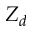<formula> <loc_0><loc_0><loc_500><loc_500>Z _ { d }</formula> 